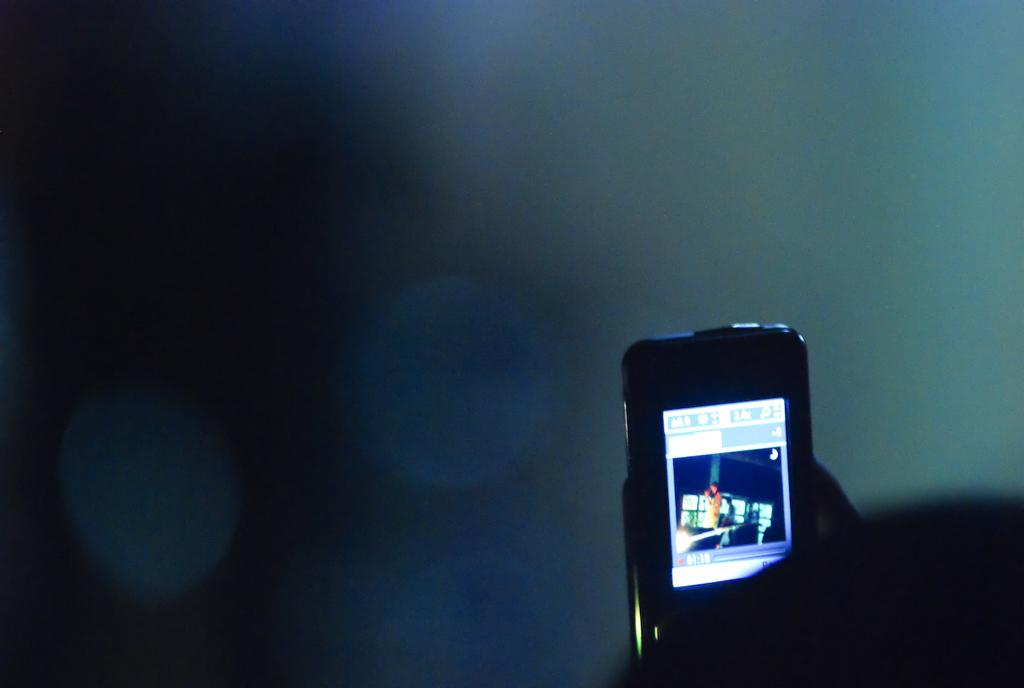What object is the main focus of the image? There is a mobile in the image. What can be observed about the background of the image? The background of the image is dark. What type of railway is visible in the image? There is no railway present in the image; it only features a mobile. How many teeth can be seen on the hen in the image? There is no hen present in the image, so it is not possible to determine the number of teeth. 